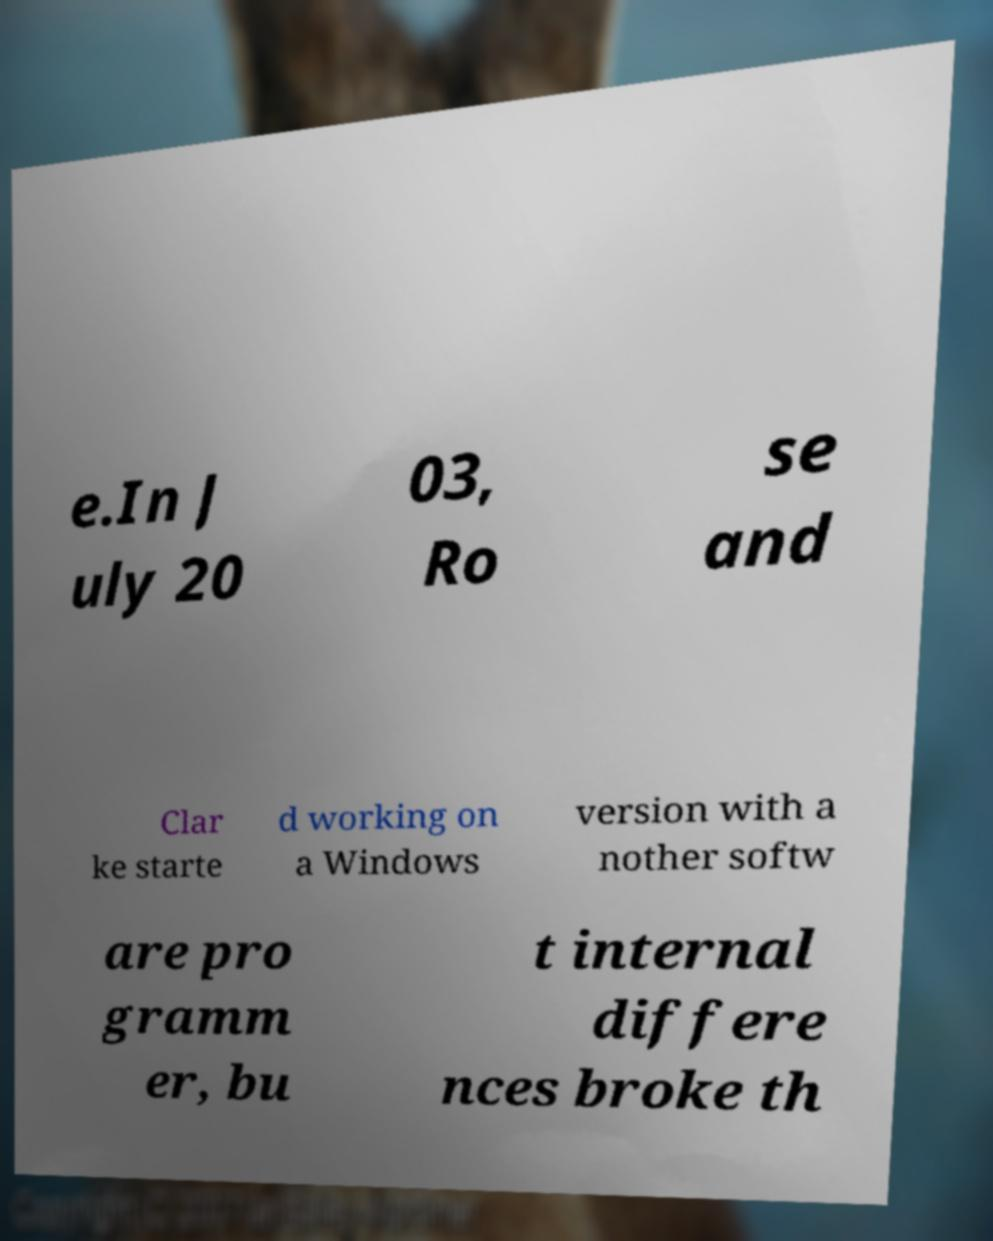There's text embedded in this image that I need extracted. Can you transcribe it verbatim? e.In J uly 20 03, Ro se and Clar ke starte d working on a Windows version with a nother softw are pro gramm er, bu t internal differe nces broke th 